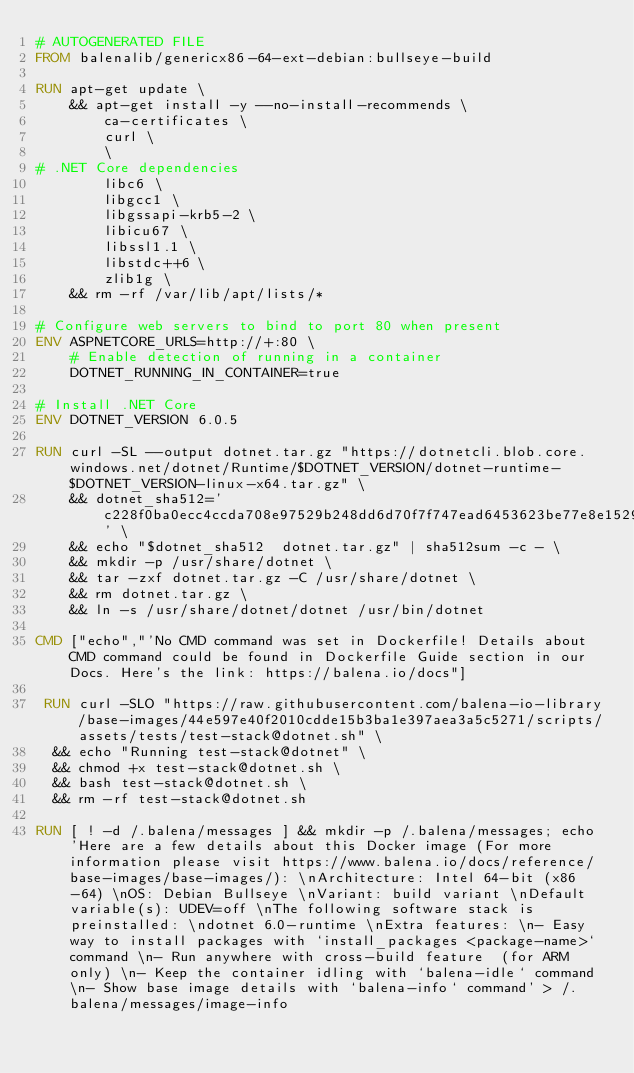<code> <loc_0><loc_0><loc_500><loc_500><_Dockerfile_># AUTOGENERATED FILE
FROM balenalib/genericx86-64-ext-debian:bullseye-build

RUN apt-get update \
    && apt-get install -y --no-install-recommends \
        ca-certificates \
        curl \
        \
# .NET Core dependencies
        libc6 \
        libgcc1 \
        libgssapi-krb5-2 \
        libicu67 \
        libssl1.1 \
        libstdc++6 \
        zlib1g \
    && rm -rf /var/lib/apt/lists/*

# Configure web servers to bind to port 80 when present
ENV ASPNETCORE_URLS=http://+:80 \
    # Enable detection of running in a container
    DOTNET_RUNNING_IN_CONTAINER=true

# Install .NET Core
ENV DOTNET_VERSION 6.0.5

RUN curl -SL --output dotnet.tar.gz "https://dotnetcli.blob.core.windows.net/dotnet/Runtime/$DOTNET_VERSION/dotnet-runtime-$DOTNET_VERSION-linux-x64.tar.gz" \
    && dotnet_sha512='c228f0ba0ecc4ccda708e97529b248dd6d70f7f747ead6453623be77e8e1529b54db52f5df1b5e00b5b7f92b73389560832f80607fc07e50879d55ce905afcf7' \
    && echo "$dotnet_sha512  dotnet.tar.gz" | sha512sum -c - \
    && mkdir -p /usr/share/dotnet \
    && tar -zxf dotnet.tar.gz -C /usr/share/dotnet \
    && rm dotnet.tar.gz \
    && ln -s /usr/share/dotnet/dotnet /usr/bin/dotnet

CMD ["echo","'No CMD command was set in Dockerfile! Details about CMD command could be found in Dockerfile Guide section in our Docs. Here's the link: https://balena.io/docs"]

 RUN curl -SLO "https://raw.githubusercontent.com/balena-io-library/base-images/44e597e40f2010cdde15b3ba1e397aea3a5c5271/scripts/assets/tests/test-stack@dotnet.sh" \
  && echo "Running test-stack@dotnet" \
  && chmod +x test-stack@dotnet.sh \
  && bash test-stack@dotnet.sh \
  && rm -rf test-stack@dotnet.sh 

RUN [ ! -d /.balena/messages ] && mkdir -p /.balena/messages; echo 'Here are a few details about this Docker image (For more information please visit https://www.balena.io/docs/reference/base-images/base-images/): \nArchitecture: Intel 64-bit (x86-64) \nOS: Debian Bullseye \nVariant: build variant \nDefault variable(s): UDEV=off \nThe following software stack is preinstalled: \ndotnet 6.0-runtime \nExtra features: \n- Easy way to install packages with `install_packages <package-name>` command \n- Run anywhere with cross-build feature  (for ARM only) \n- Keep the container idling with `balena-idle` command \n- Show base image details with `balena-info` command' > /.balena/messages/image-info</code> 